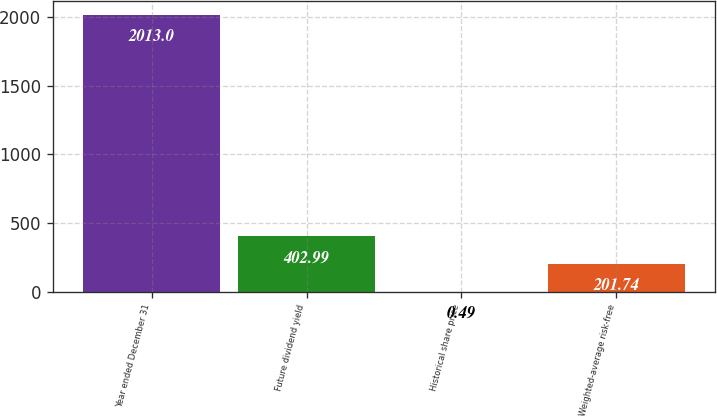Convert chart. <chart><loc_0><loc_0><loc_500><loc_500><bar_chart><fcel>Year ended December 31<fcel>Future dividend yield<fcel>Historical share price<fcel>Weighted-average risk-free<nl><fcel>2013<fcel>402.99<fcel>0.49<fcel>201.74<nl></chart> 